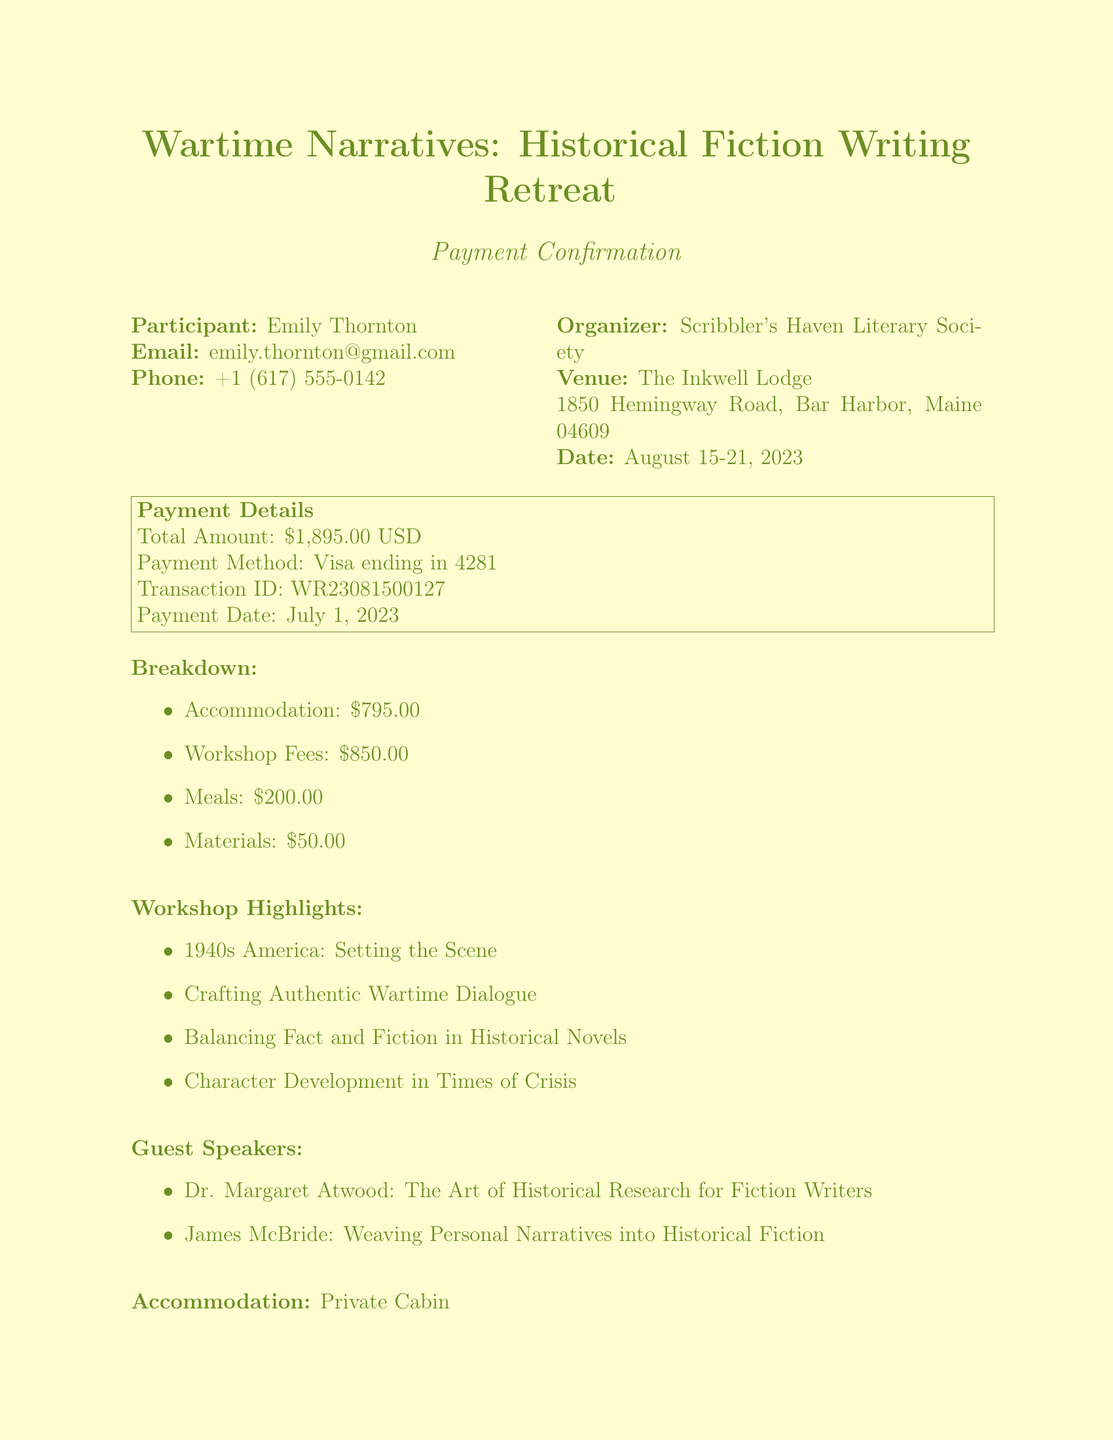What is the name of the retreat? The name of the retreat is indicated at the beginning of the document and is "Wartime Narratives: Historical Fiction Writing Retreat."
Answer: Wartime Narratives: Historical Fiction Writing Retreat Who is the organizer of the retreat? The organizer is stated under the organizer section of the document.
Answer: Scribbler's Haven Literary Society What is the total amount paid? The total amount paid is shown in the payment details, which lists the total due for the retreat.
Answer: 1895.00 What is the payment method used? The payment method is specified in the payment details section, indicating how the payment was made.
Answer: Visa ending in 4281 What are the dates for the retreat? The dates for the retreat are provided clearly in the venue section of the document.
Answer: August 15-21, 2023 What is included in the accommodation amenities? Specific amenities are listed under accommodation details and describe what is provided in the private cabin.
Answer: Writing desk, Vintage typewriter, Mini-library of WWII-era books, Daily housekeeping What happens if I cancel my registration 10 days before the retreat? The cancellation policy provides information about the refund structure based on when the cancellation occurs, specifically for less than 14 days.
Answer: No refund Name one guest speaker and their topic. Guest speakers and their topics are listed, providing names and themes discussed during the retreat.
Answer: Dr. Margaret Atwood: The Art of Historical Research for Fiction Writers How much is allocated for meals in the payment breakdown? The payment breakdown specifies how much of the total amount goes towards meals, among other costs.
Answer: 200.00 